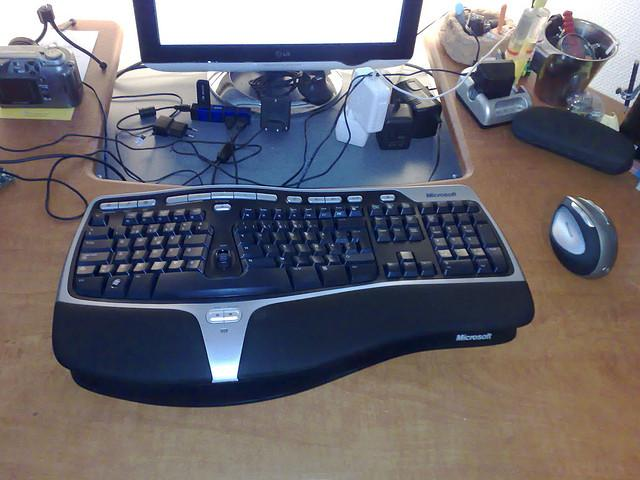What are the corded objects used for? Please explain your reasoning. powering devices. The cords put power to the devices. 